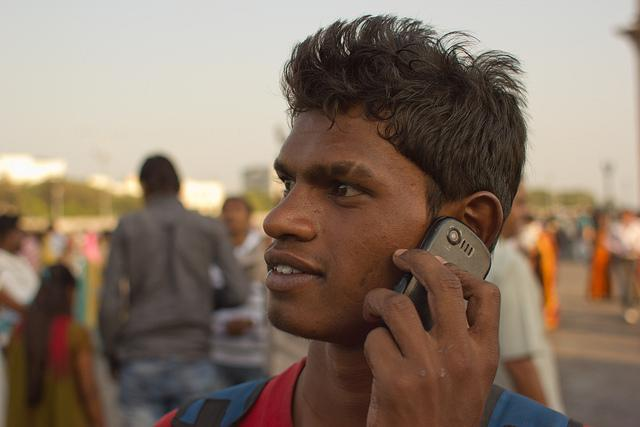What is a famous company that makes the device the man is holding? samsung 